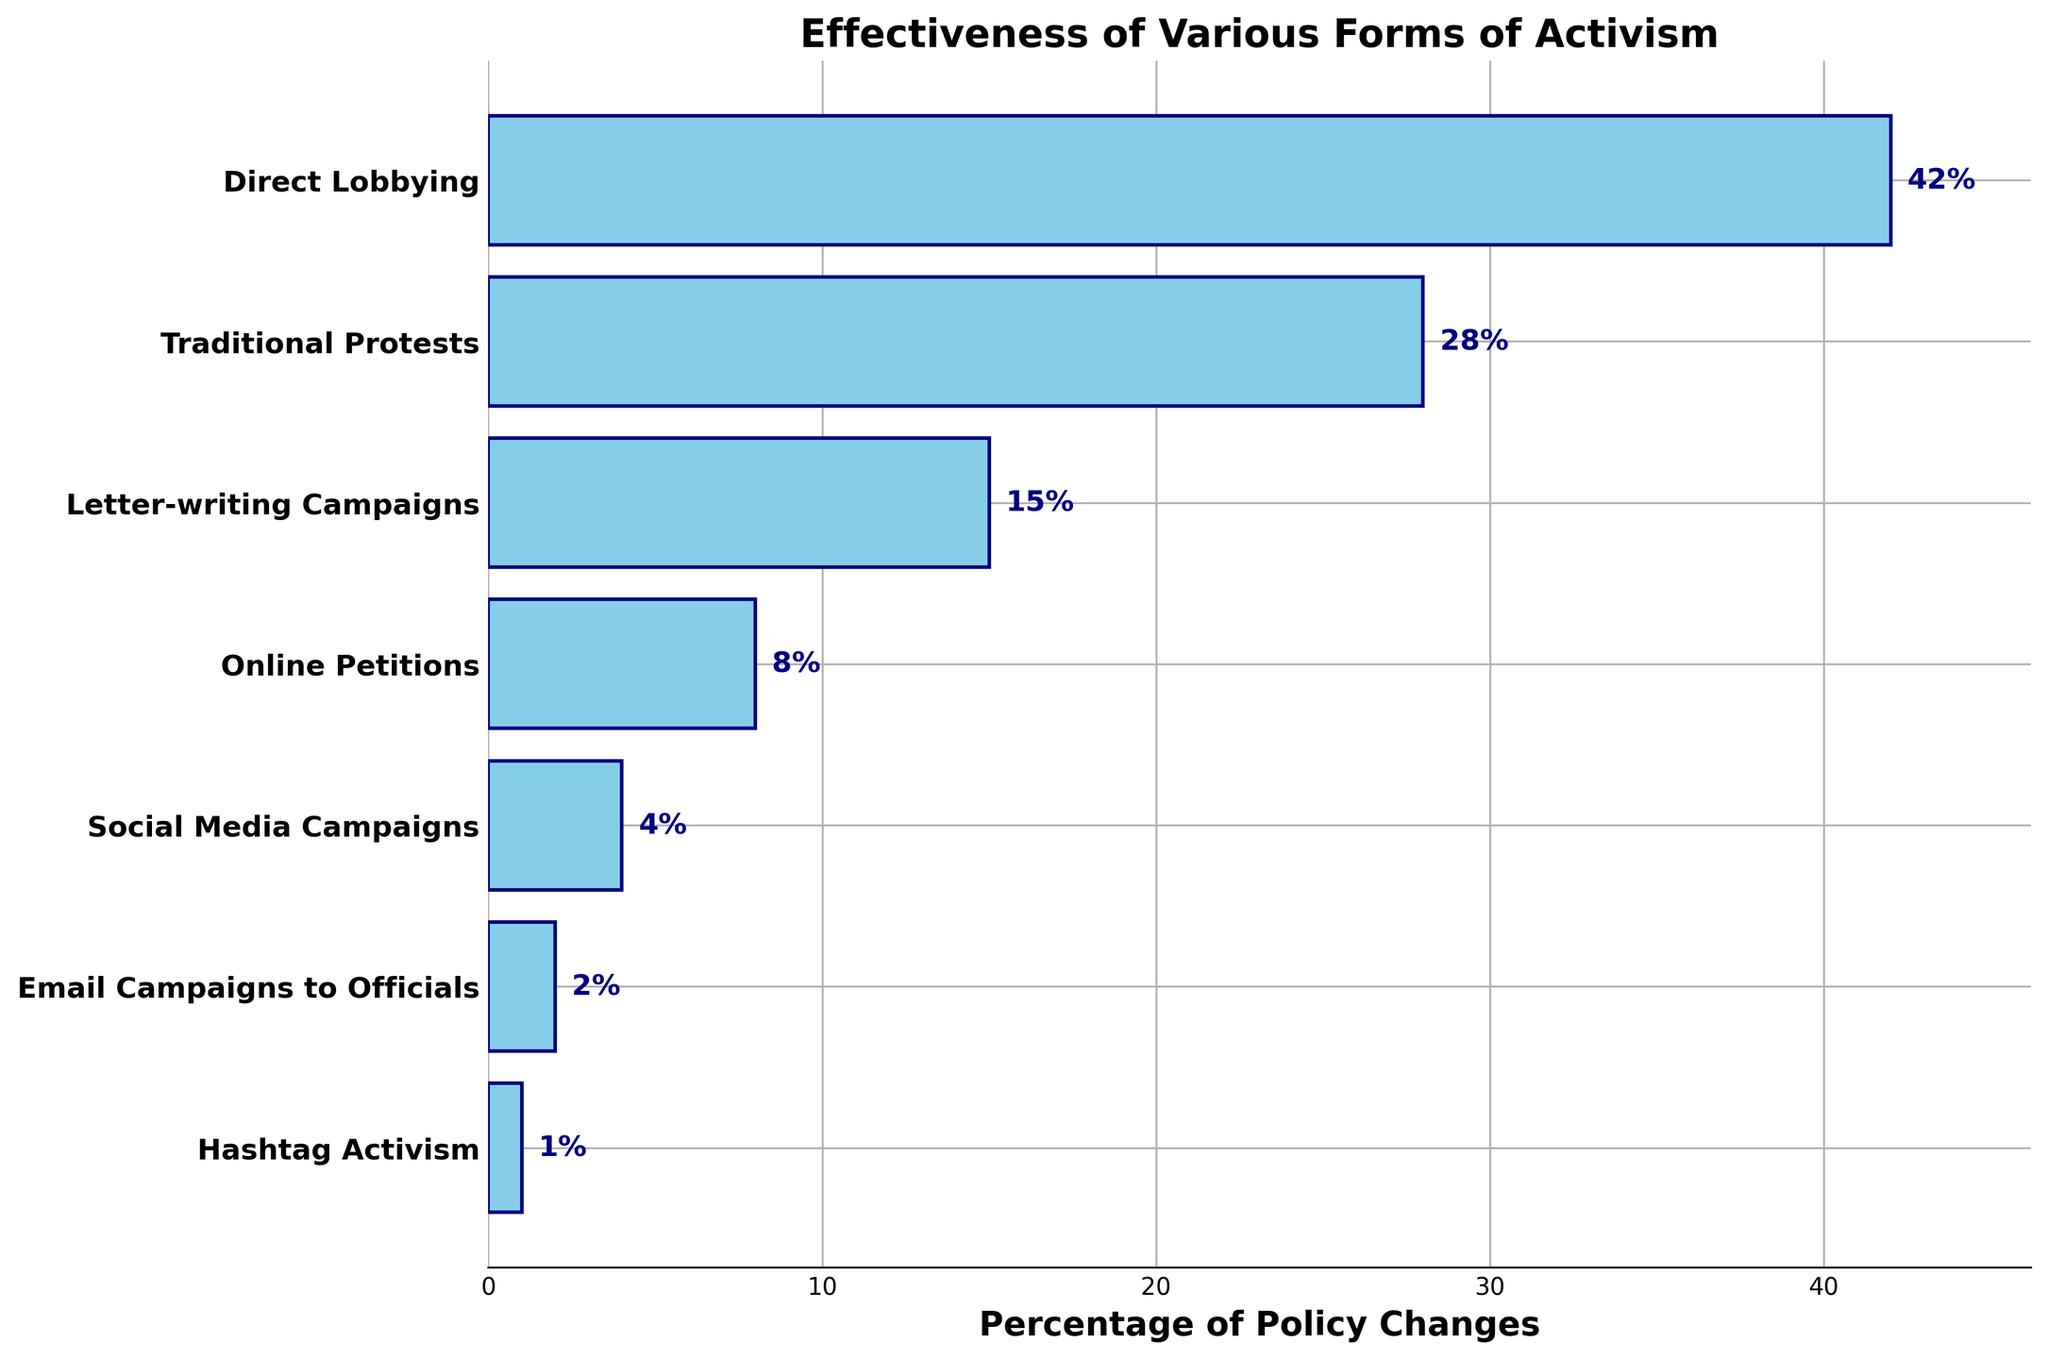what form of activism has the highest percentage of policy changes? The longest bar represents the form of activism with the highest percentage of policy changes. In this figure, the longest bar corresponds to Direct Lobbying at 42%.
Answer: Direct Lobbying what is the total percentage of policy changes attributed to Traditional Protests and Online Petitions? Sum the percentage values for Traditional Protests and Online Petitions. Traditional Protests is 28% and Online Petitions is 8%, so 28% + 8% = 36%
Answer: 36% Which forms of activism contribute less than 10% to policy changes? Look for bars that are shorter and have percentages less than 10%. These forms are Online Petitions (8%), Social Media Campaigns (4%), Email Campaigns to Officials (2%), and Hashtag Activism (1%).
Answer: Online Petitions, Social Media Campaigns, Email Campaigns to Officials, Hashtag Activism How much greater is the percentage of policy changes attributed to Direct Lobbying compared to Email Campaigns to Officials? Subtract the percentage of Email Campaigns to Officials from Direct Lobbying. Direct Lobbying is 42% and Email Campaigns to Officials is 2%, so 42% - 2% = 40%
Answer: 40% What is the average percentage of policy changes for Traditional Protests, Letter-writing Campaigns, and Social Media Campaigns? Sum the percentages of Traditional Protests, Letter-writing Campaigns, and Social Media Campaigns and then divide by 3. (28% + 15% + 4%) / 3 = 47% / 3 ≈ 15.67%
Answer: 15.67% Which is more effective in achieving policy changes, Social Media Campaigns or Email Campaigns to Officials? Compare the lengths of the bars for Social Media Campaigns and Email Campaigns to Officials. Social Media Campaigns have 4%, and Email Campaigns to Officials have 2%. 4% is greater than 2%.
Answer: Social Media Campaigns How many times more effective is Direct Lobbying compared to Hashtag Activism? Divide the percentage of Direct Lobbying by the percentage of Hashtag Activism. Direct Lobbying is 42% and Hashtag Activism is 1%, so 42% / 1% = 42 times
Answer: 42 times What is the combined percentage of policy changes attributed to all online forms of activism listed? Sum the percentages for Online Petitions, Social Media Campaigns, Email Campaigns to Officials, and Hashtag Activism. (8% + 4% + 2% + 1%) = 15%
Answer: 15% 